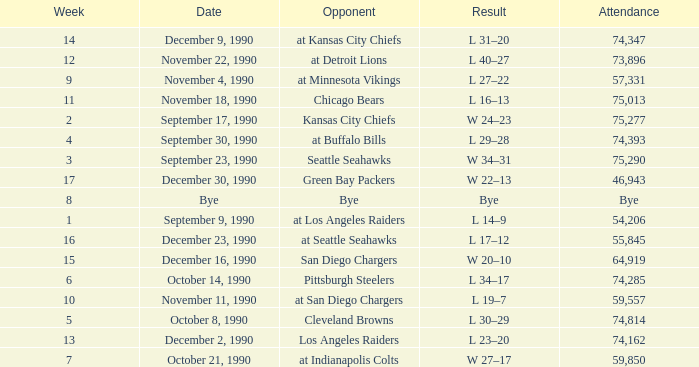Who is the opponent when the attendance is 57,331? At minnesota vikings. 